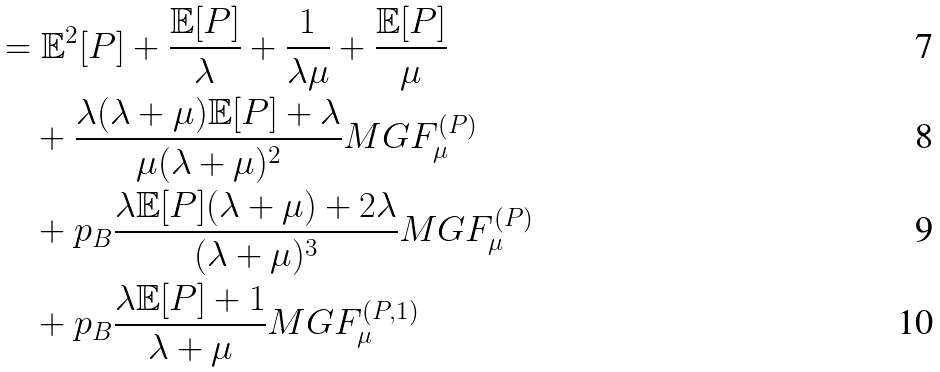<formula> <loc_0><loc_0><loc_500><loc_500>& = \mathbb { E } ^ { 2 } [ P ] + \frac { \mathbb { E } [ P ] } { \lambda } + \frac { 1 } { \lambda \mu } + \frac { \mathbb { E } [ P ] } { \mu } \\ & \quad + \frac { \lambda ( \lambda + \mu ) \mathbb { E } [ P ] + \lambda } { \mu ( \lambda + \mu ) ^ { 2 } } M G F _ { \mu } ^ { ( P ) } \\ & \quad + p _ { B } \frac { \lambda \mathbb { E } [ P ] ( \lambda + \mu ) + 2 \lambda } { ( \lambda + \mu ) ^ { 3 } } M G F _ { \mu } ^ { ( P ) } \\ & \quad + p _ { B } \frac { \lambda \mathbb { E } [ P ] + 1 } { \lambda + \mu } M G F _ { \mu } ^ { ( P , 1 ) }</formula> 